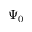Convert formula to latex. <formula><loc_0><loc_0><loc_500><loc_500>\Psi _ { 0 }</formula> 